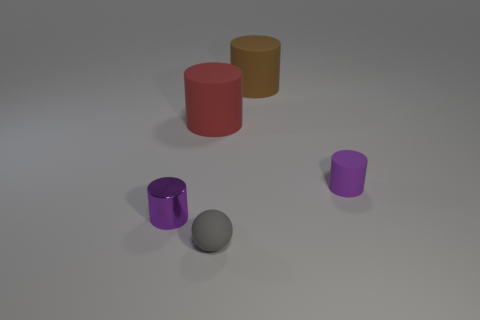Is the size of the purple thing that is in front of the purple matte thing the same as the sphere?
Offer a very short reply. Yes. What is the shape of the big red matte thing?
Offer a terse response. Cylinder. The other cylinder that is the same color as the small matte cylinder is what size?
Give a very brief answer. Small. Does the small purple thing on the left side of the ball have the same material as the tiny gray thing?
Offer a very short reply. No. Is there a small matte cylinder of the same color as the ball?
Give a very brief answer. No. There is a matte thing in front of the tiny purple matte cylinder; is its shape the same as the matte object that is behind the red matte cylinder?
Your response must be concise. No. Is there a tiny gray thing made of the same material as the big brown cylinder?
Your answer should be very brief. Yes. How many brown things are either tiny cylinders or small matte spheres?
Provide a succinct answer. 0. What size is the cylinder that is both to the right of the big red rubber cylinder and in front of the brown matte thing?
Offer a terse response. Small. Is the number of rubber cylinders to the right of the small gray rubber thing greater than the number of yellow objects?
Provide a short and direct response. Yes. 